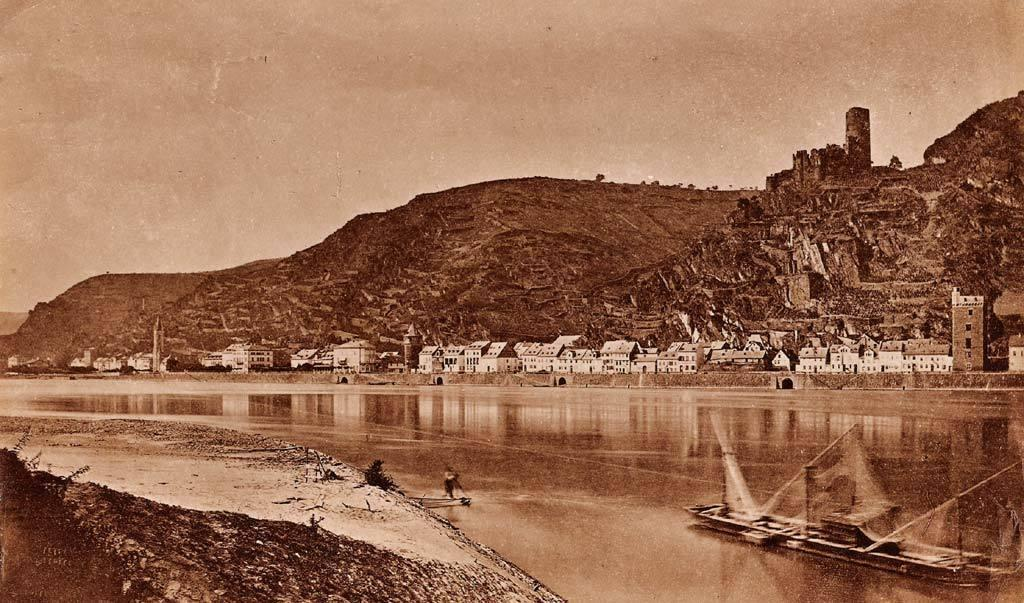What is the main subject of the image? The main subject of the image is a boat. Where is the boat located? The boat is on the water. What can be seen in the background of the image? There are buildings and hills in the background of the image. What type of apparel are the babies wearing in the image? There are no babies or apparel present in the image; it features a boat on the water with buildings and hills in the background. 